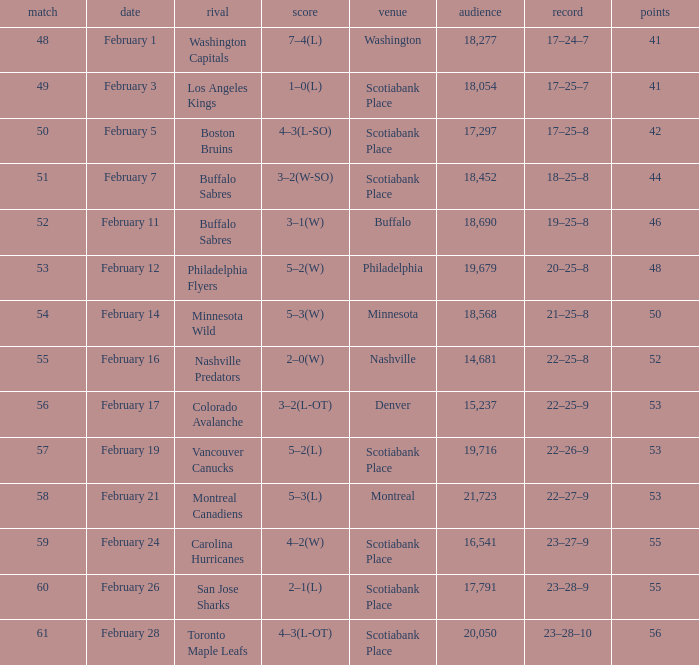What average game was held on february 24 and has an attendance smaller than 16,541? None. 